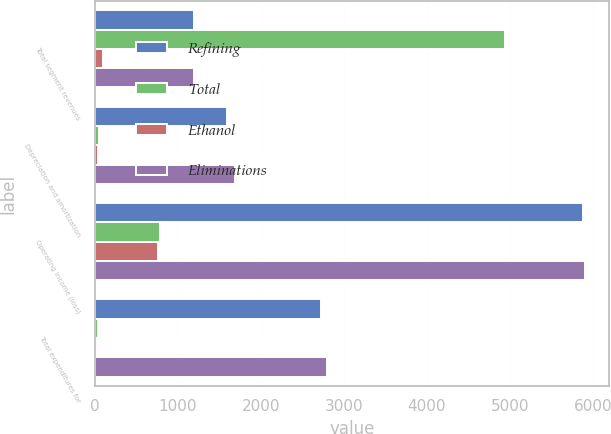<chart> <loc_0><loc_0><loc_500><loc_500><stacked_bar_chart><ecel><fcel>Total segment revenues<fcel>Depreciation and amortization<fcel>Operating income (loss)<fcel>Total expenditures for<nl><fcel>Refining<fcel>1191.5<fcel>1597<fcel>5884<fcel>2730<nl><fcel>Total<fcel>4940<fcel>49<fcel>786<fcel>42<nl><fcel>Ethanol<fcel>100<fcel>44<fcel>768<fcel>30<nl><fcel>Eliminations<fcel>1191.5<fcel>1690<fcel>5902<fcel>2802<nl></chart> 